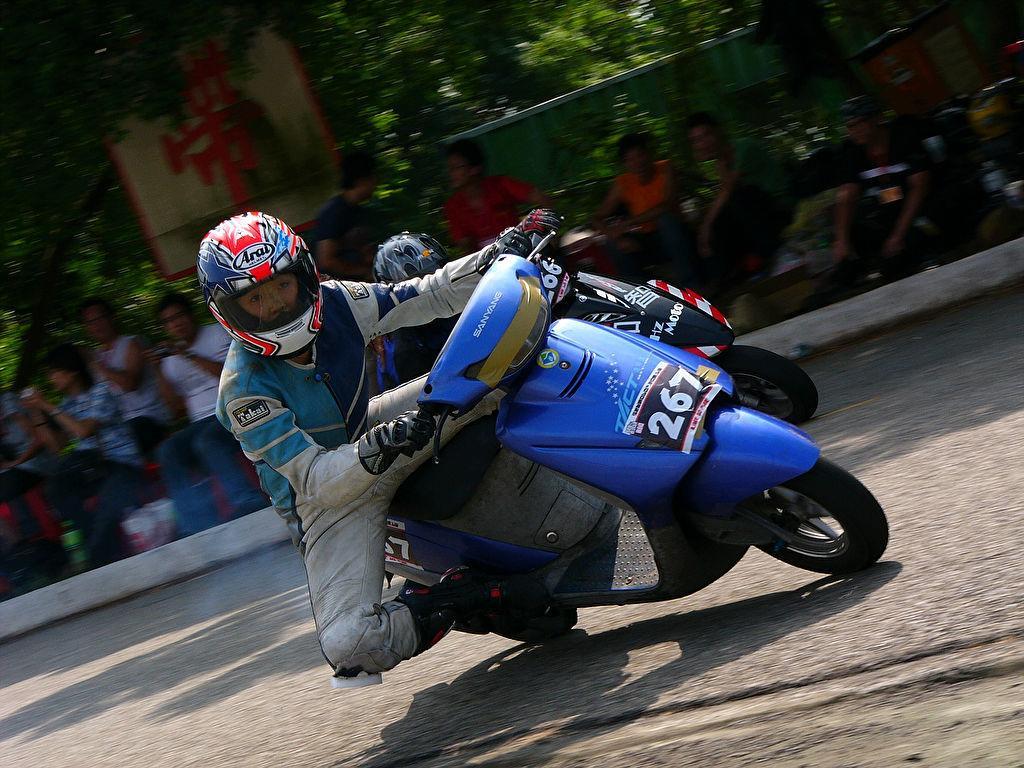Describe this image in one or two sentences. In this image two persons are sitting on the motorcycles. They are wearing helmets. Behind there are few persons sitting before the fence. Left top there is a board. Background there are few trees. 